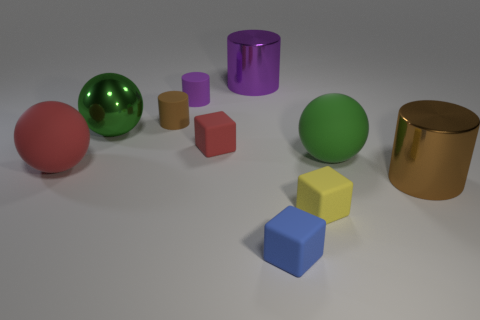Subtract 1 cylinders. How many cylinders are left? 3 Subtract all balls. How many objects are left? 7 Subtract all red rubber spheres. Subtract all blue cubes. How many objects are left? 8 Add 1 large matte objects. How many large matte objects are left? 3 Add 6 brown matte cylinders. How many brown matte cylinders exist? 7 Subtract 0 gray cubes. How many objects are left? 10 